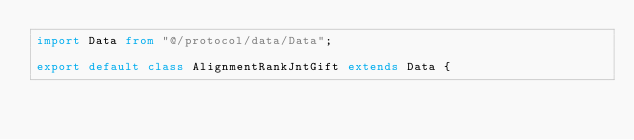Convert code to text. <code><loc_0><loc_0><loc_500><loc_500><_TypeScript_>import Data from "@/protocol/data/Data";

export default class AlignmentRankJntGift extends Data {</code> 